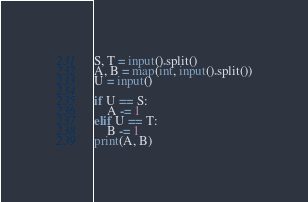Convert code to text. <code><loc_0><loc_0><loc_500><loc_500><_Python_>S, T = input().split()
A, B = map(int, input().split())
U = input()

if U == S:
    A -= 1
elif U == T:
    B -= 1
print(A, B)
</code> 